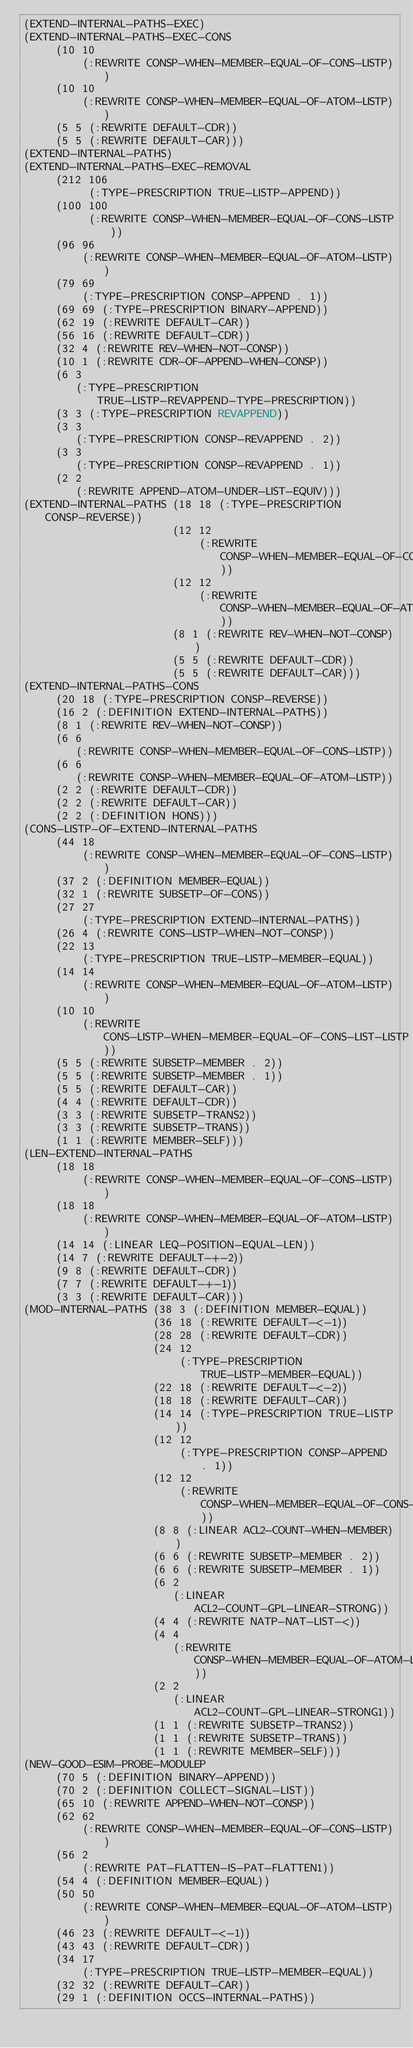<code> <loc_0><loc_0><loc_500><loc_500><_Lisp_>(EXTEND-INTERNAL-PATHS-EXEC)
(EXTEND-INTERNAL-PATHS-EXEC-CONS
     (10 10
         (:REWRITE CONSP-WHEN-MEMBER-EQUAL-OF-CONS-LISTP))
     (10 10
         (:REWRITE CONSP-WHEN-MEMBER-EQUAL-OF-ATOM-LISTP))
     (5 5 (:REWRITE DEFAULT-CDR))
     (5 5 (:REWRITE DEFAULT-CAR)))
(EXTEND-INTERNAL-PATHS)
(EXTEND-INTERNAL-PATHS-EXEC-REMOVAL
     (212 106
          (:TYPE-PRESCRIPTION TRUE-LISTP-APPEND))
     (100 100
          (:REWRITE CONSP-WHEN-MEMBER-EQUAL-OF-CONS-LISTP))
     (96 96
         (:REWRITE CONSP-WHEN-MEMBER-EQUAL-OF-ATOM-LISTP))
     (79 69
         (:TYPE-PRESCRIPTION CONSP-APPEND . 1))
     (69 69 (:TYPE-PRESCRIPTION BINARY-APPEND))
     (62 19 (:REWRITE DEFAULT-CAR))
     (56 16 (:REWRITE DEFAULT-CDR))
     (32 4 (:REWRITE REV-WHEN-NOT-CONSP))
     (10 1 (:REWRITE CDR-OF-APPEND-WHEN-CONSP))
     (6 3
        (:TYPE-PRESCRIPTION TRUE-LISTP-REVAPPEND-TYPE-PRESCRIPTION))
     (3 3 (:TYPE-PRESCRIPTION REVAPPEND))
     (3 3
        (:TYPE-PRESCRIPTION CONSP-REVAPPEND . 2))
     (3 3
        (:TYPE-PRESCRIPTION CONSP-REVAPPEND . 1))
     (2 2
        (:REWRITE APPEND-ATOM-UNDER-LIST-EQUIV)))
(EXTEND-INTERNAL-PATHS (18 18 (:TYPE-PRESCRIPTION CONSP-REVERSE))
                       (12 12
                           (:REWRITE CONSP-WHEN-MEMBER-EQUAL-OF-CONS-LISTP))
                       (12 12
                           (:REWRITE CONSP-WHEN-MEMBER-EQUAL-OF-ATOM-LISTP))
                       (8 1 (:REWRITE REV-WHEN-NOT-CONSP))
                       (5 5 (:REWRITE DEFAULT-CDR))
                       (5 5 (:REWRITE DEFAULT-CAR)))
(EXTEND-INTERNAL-PATHS-CONS
     (20 18 (:TYPE-PRESCRIPTION CONSP-REVERSE))
     (16 2 (:DEFINITION EXTEND-INTERNAL-PATHS))
     (8 1 (:REWRITE REV-WHEN-NOT-CONSP))
     (6 6
        (:REWRITE CONSP-WHEN-MEMBER-EQUAL-OF-CONS-LISTP))
     (6 6
        (:REWRITE CONSP-WHEN-MEMBER-EQUAL-OF-ATOM-LISTP))
     (2 2 (:REWRITE DEFAULT-CDR))
     (2 2 (:REWRITE DEFAULT-CAR))
     (2 2 (:DEFINITION HONS)))
(CONS-LISTP-OF-EXTEND-INTERNAL-PATHS
     (44 18
         (:REWRITE CONSP-WHEN-MEMBER-EQUAL-OF-CONS-LISTP))
     (37 2 (:DEFINITION MEMBER-EQUAL))
     (32 1 (:REWRITE SUBSETP-OF-CONS))
     (27 27
         (:TYPE-PRESCRIPTION EXTEND-INTERNAL-PATHS))
     (26 4 (:REWRITE CONS-LISTP-WHEN-NOT-CONSP))
     (22 13
         (:TYPE-PRESCRIPTION TRUE-LISTP-MEMBER-EQUAL))
     (14 14
         (:REWRITE CONSP-WHEN-MEMBER-EQUAL-OF-ATOM-LISTP))
     (10 10
         (:REWRITE CONS-LISTP-WHEN-MEMBER-EQUAL-OF-CONS-LIST-LISTP))
     (5 5 (:REWRITE SUBSETP-MEMBER . 2))
     (5 5 (:REWRITE SUBSETP-MEMBER . 1))
     (5 5 (:REWRITE DEFAULT-CAR))
     (4 4 (:REWRITE DEFAULT-CDR))
     (3 3 (:REWRITE SUBSETP-TRANS2))
     (3 3 (:REWRITE SUBSETP-TRANS))
     (1 1 (:REWRITE MEMBER-SELF)))
(LEN-EXTEND-INTERNAL-PATHS
     (18 18
         (:REWRITE CONSP-WHEN-MEMBER-EQUAL-OF-CONS-LISTP))
     (18 18
         (:REWRITE CONSP-WHEN-MEMBER-EQUAL-OF-ATOM-LISTP))
     (14 14 (:LINEAR LEQ-POSITION-EQUAL-LEN))
     (14 7 (:REWRITE DEFAULT-+-2))
     (9 8 (:REWRITE DEFAULT-CDR))
     (7 7 (:REWRITE DEFAULT-+-1))
     (3 3 (:REWRITE DEFAULT-CAR)))
(MOD-INTERNAL-PATHS (38 3 (:DEFINITION MEMBER-EQUAL))
                    (36 18 (:REWRITE DEFAULT-<-1))
                    (28 28 (:REWRITE DEFAULT-CDR))
                    (24 12
                        (:TYPE-PRESCRIPTION TRUE-LISTP-MEMBER-EQUAL))
                    (22 18 (:REWRITE DEFAULT-<-2))
                    (18 18 (:REWRITE DEFAULT-CAR))
                    (14 14 (:TYPE-PRESCRIPTION TRUE-LISTP))
                    (12 12
                        (:TYPE-PRESCRIPTION CONSP-APPEND . 1))
                    (12 12
                        (:REWRITE CONSP-WHEN-MEMBER-EQUAL-OF-CONS-LISTP))
                    (8 8 (:LINEAR ACL2-COUNT-WHEN-MEMBER))
                    (6 6 (:REWRITE SUBSETP-MEMBER . 2))
                    (6 6 (:REWRITE SUBSETP-MEMBER . 1))
                    (6 2
                       (:LINEAR ACL2-COUNT-GPL-LINEAR-STRONG))
                    (4 4 (:REWRITE NATP-NAT-LIST-<))
                    (4 4
                       (:REWRITE CONSP-WHEN-MEMBER-EQUAL-OF-ATOM-LISTP))
                    (2 2
                       (:LINEAR ACL2-COUNT-GPL-LINEAR-STRONG1))
                    (1 1 (:REWRITE SUBSETP-TRANS2))
                    (1 1 (:REWRITE SUBSETP-TRANS))
                    (1 1 (:REWRITE MEMBER-SELF)))
(NEW-GOOD-ESIM-PROBE-MODULEP
     (70 5 (:DEFINITION BINARY-APPEND))
     (70 2 (:DEFINITION COLLECT-SIGNAL-LIST))
     (65 10 (:REWRITE APPEND-WHEN-NOT-CONSP))
     (62 62
         (:REWRITE CONSP-WHEN-MEMBER-EQUAL-OF-CONS-LISTP))
     (56 2
         (:REWRITE PAT-FLATTEN-IS-PAT-FLATTEN1))
     (54 4 (:DEFINITION MEMBER-EQUAL))
     (50 50
         (:REWRITE CONSP-WHEN-MEMBER-EQUAL-OF-ATOM-LISTP))
     (46 23 (:REWRITE DEFAULT-<-1))
     (43 43 (:REWRITE DEFAULT-CDR))
     (34 17
         (:TYPE-PRESCRIPTION TRUE-LISTP-MEMBER-EQUAL))
     (32 32 (:REWRITE DEFAULT-CAR))
     (29 1 (:DEFINITION OCCS-INTERNAL-PATHS))</code> 